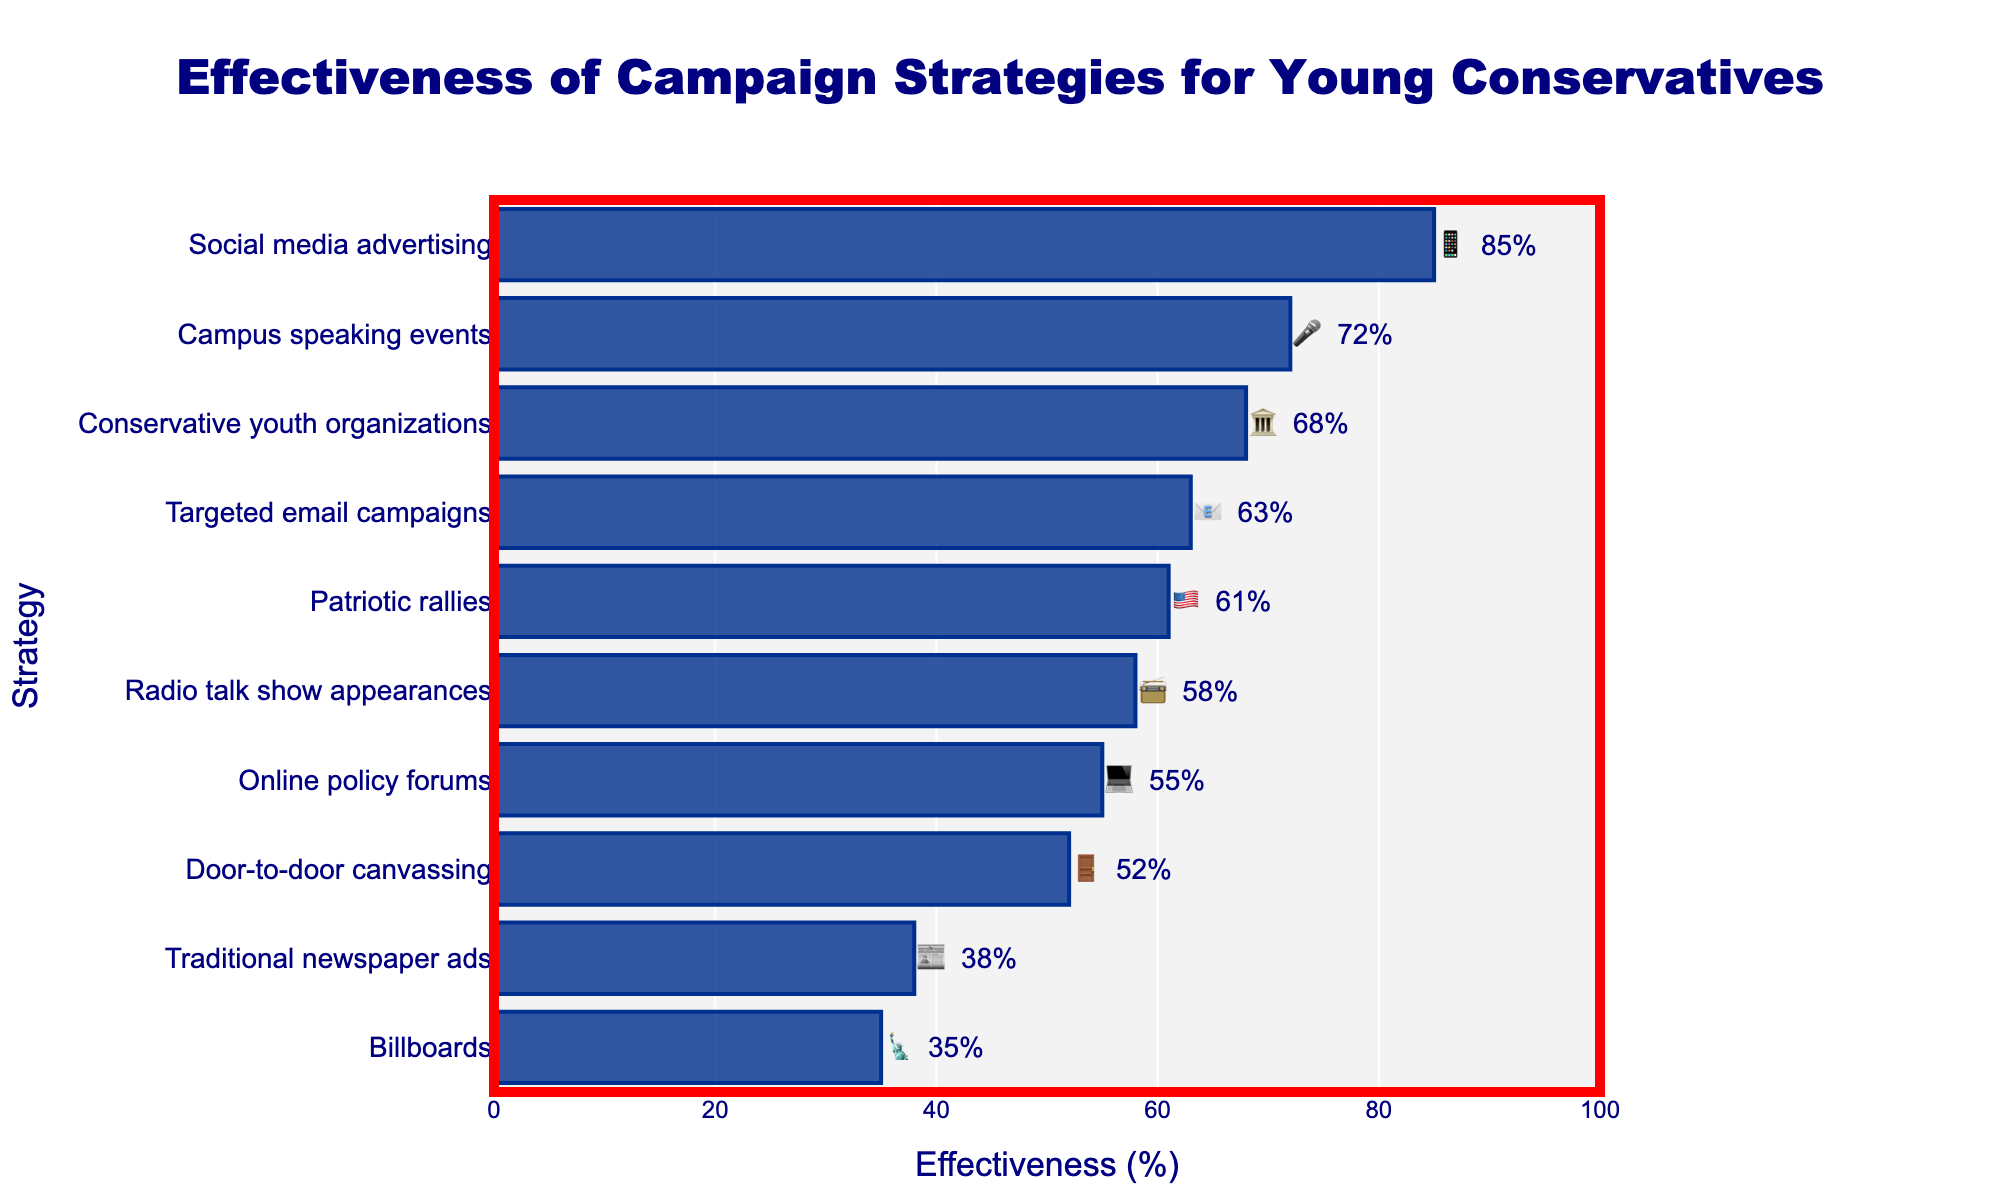What is the effectiveness of social media advertising for young conservatives 📱? Referring to the horizontal bar chart, we can see that the effectiveness of social media advertising is shown as 85%, which is labeled next to the corresponding bar.
Answer: 85% Which campaign strategy has the lowest effectiveness 🗽? By observing the bottom-most bar of the chart, labeled with an emoji and effectiveness percentage, we find that billboards have the lowest effectiveness at 35%.
Answer: Billboards What is the combined effectiveness of campus speaking events 🎤 and targeted email campaigns 📧? The effectiveness of campus speaking events is 72%, and targeted email campaigns is 63%. Adding these together we get 72 + 63 = 135%.
Answer: 135% Which strategy is more effective: patriotic rallies 🇺🇸 or radio talk show appearances 📻? Comparing the bars for patriotic rallies and radio talk show appearances, we see that patriotic rallies have an effectiveness of 61%, and radio talk show appearances have 58%. Therefore, patriotic rallies are more effective.
Answer: Patriotic rallies How many campaign strategies have an effectiveness above 60%? Observing the chart, the bars with effectiveness percentages above 60% are: social media advertising (85%), campus speaking events (72%), conservative youth organizations (68%), targeted email campaigns (63%), and patriotic rallies (61%). There are 5 such strategies.
Answer: 5 What is the average effectiveness of all the campaign strategies listed? Summing up all the effectiveness percentages: 85 + 72 + 68 + 63 + 61 + 58 + 55 + 52 + 38 + 35 = 587. Dividing this sum by the number of strategies (10), the average effectiveness is 587 / 10 = 58.7%.
Answer: 58.7% Are traditional newspaper ads more or less effective than online policy forums? The effectiveness of traditional newspaper ads is 38%, and online policy forums is 55%. Therefore, traditional newspaper ads are less effective.
Answer: Less Between door-to-door canvassing 🚪 and billboards 🗽, which has higher effectiveness? Referring to the chart, the effectiveness of door-to-door canvassing is 52%, while billboards is 35%. Thus, door-to-door canvassing is higher.
Answer: Door-to-door canvassing What is the median effectiveness value of the given campaign strategies? To find the median, we sort the effectiveness values: 35, 38, 52, 55, 58, 61, 63, 68, 72, 85. With an even number of values (10), the median is the average of the middle two values (58 and 61). Thus, the median effectiveness is (58 + 61) / 2 = 59.5%.
Answer: 59.5% Which campaign strategy used the emoji 🏛️ and what is its effectiveness? The chart shows that the conservative youth organizations strategy uses the 🏛️ emoji and has an effectiveness of 68%.
Answer: Conservative youth organizations, 68% 